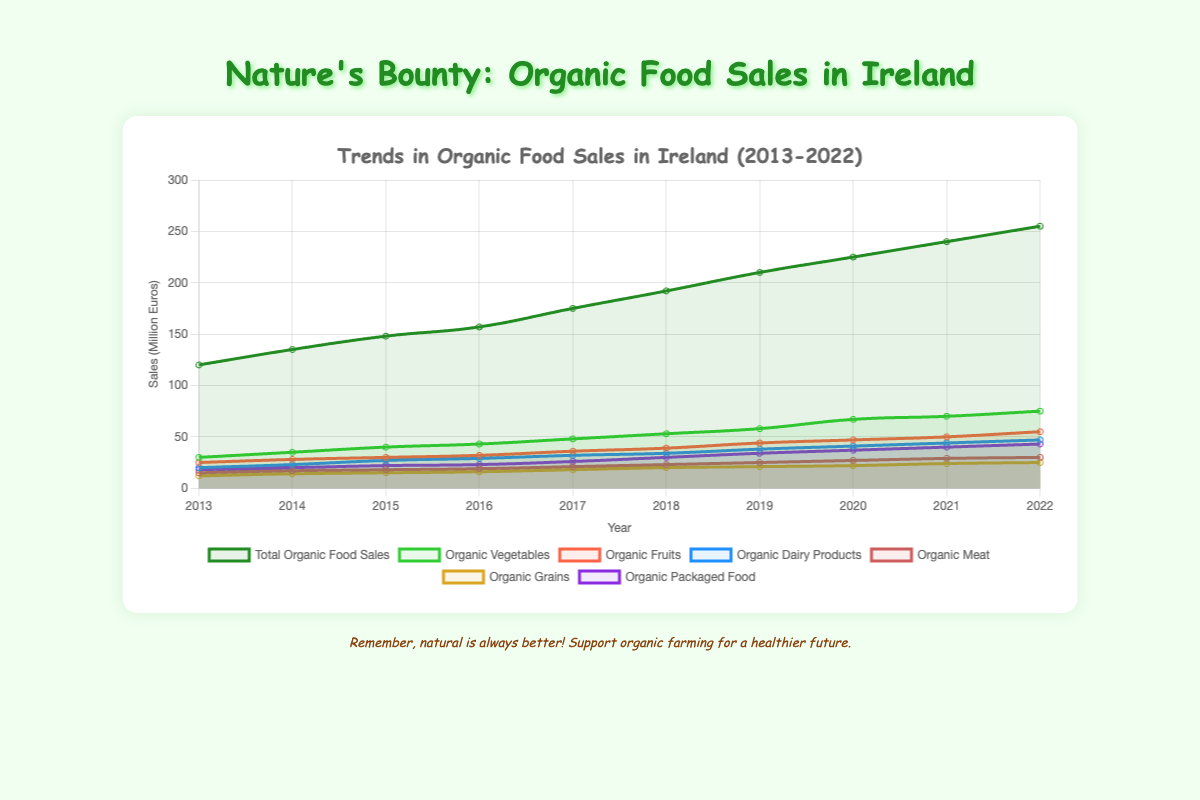What is the overall trend in total organic food sales from 2013 to 2022? The total organic food sales have increased each year. Comparing the values from 2013 (€120 million) and 2022 (€255 million) shows a steady upward trend.
Answer: Increasing Which category had the highest sales in 2022? Looking at the 2022 data for each category, organic vegetables had the highest sales with €75 million.
Answer: Organic vegetables What is the difference in organic fruit sales between 2015 and 2022? The sales in 2015 were €30 million, and in 2022 they were €55 million. Subtracting the two gives €55 million - €30 million = €25 million.
Answer: €25 million Which year had the largest increase in total organic food sales compared to the previous year? The year-on-year differences in total sales are: (2014-2013) €15 million, (2015-2014) €13 million, (2016-2015) €9 million, (2017-2016) €18 million, (2018-2017) €17 million, (2019-2018) €18 million, (2020-2019) €15 million, (2021-2020) €15 million, and (2022-2021) €15 million. The largest increase was 18 million in 2017 and 2019.
Answer: 2017, 2019 How much more were the sales of organic dairy products compared to organic grains in 2019? In 2019, the sales of organic dairy products were €38 million and organic grains were €21 million. The difference is €38 million - €21 million = €17 million.
Answer: €17 million What is the average sales of organic packaged food from 2018 to 2020? The sales for those years were €30 million, €34 million, and €37 million. Adding these gives (30 + 34 + 37) = 101, and the average is 101/3 ≈ 33.67 million.
Answer: €33.67 million Which category had a more significant increase in sales from 2013 to 2022: organic meat or organic fruits? Sales for organic meat in 2013 were €15 million and in 2022 €30 million, an increase of €15 million. For organic fruits, sales were €25 million in 2013 and €55 million in 2022, an increase of €30 million. Organic fruits had a larger increase.
Answer: Organic fruits How did the sales of organic vegetables change from 2020 to 2022? The sales in 2020 were €67 million and increased to €75 million in 2022. The difference is €75 million - €67 million = €8 million.
Answer: Increased by €8 million Which two categories had the closest sales figures in 2018? In 2018, the sales were: vegetables €53 million, fruits €39 million, dairy products €34 million, meat €23 million, grains €20 million, and packaged food €30 million. The closest figures are organic dairy products (€34 million) and organic packaged food (€30 million).
Answer: Organic dairy products and organic packaged food 